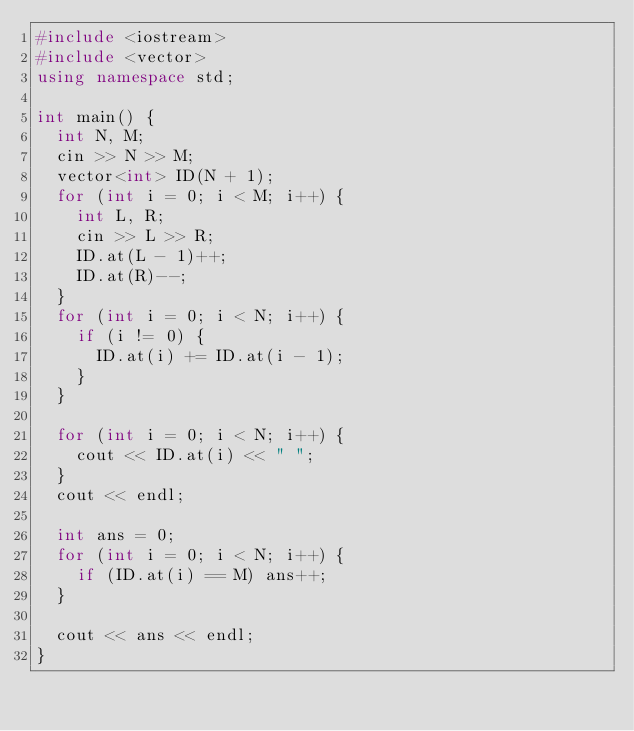Convert code to text. <code><loc_0><loc_0><loc_500><loc_500><_C++_>#include <iostream>
#include <vector>
using namespace std;

int main() {
	int N, M;
	cin >> N >> M;
	vector<int> ID(N + 1);
	for (int i = 0; i < M; i++) {
		int L, R;
		cin >> L >> R;
		ID.at(L - 1)++;
		ID.at(R)--;
	}
	for (int i = 0; i < N; i++) {
		if (i != 0) {
			ID.at(i) += ID.at(i - 1);
		}
	}

	for (int i = 0; i < N; i++) {
		cout << ID.at(i) << " ";
	}
	cout << endl;

	int ans = 0;
	for (int i = 0; i < N; i++) {
		if (ID.at(i) == M) ans++;
	}

	cout << ans << endl;
}</code> 